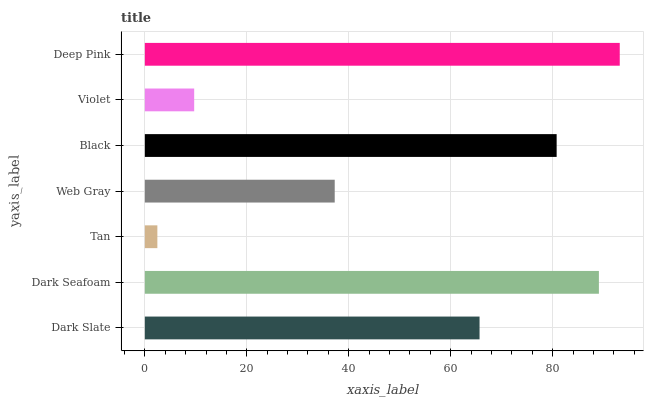Is Tan the minimum?
Answer yes or no. Yes. Is Deep Pink the maximum?
Answer yes or no. Yes. Is Dark Seafoam the minimum?
Answer yes or no. No. Is Dark Seafoam the maximum?
Answer yes or no. No. Is Dark Seafoam greater than Dark Slate?
Answer yes or no. Yes. Is Dark Slate less than Dark Seafoam?
Answer yes or no. Yes. Is Dark Slate greater than Dark Seafoam?
Answer yes or no. No. Is Dark Seafoam less than Dark Slate?
Answer yes or no. No. Is Dark Slate the high median?
Answer yes or no. Yes. Is Dark Slate the low median?
Answer yes or no. Yes. Is Violet the high median?
Answer yes or no. No. Is Black the low median?
Answer yes or no. No. 